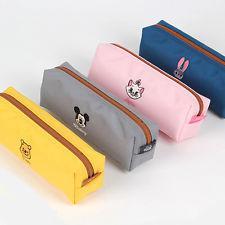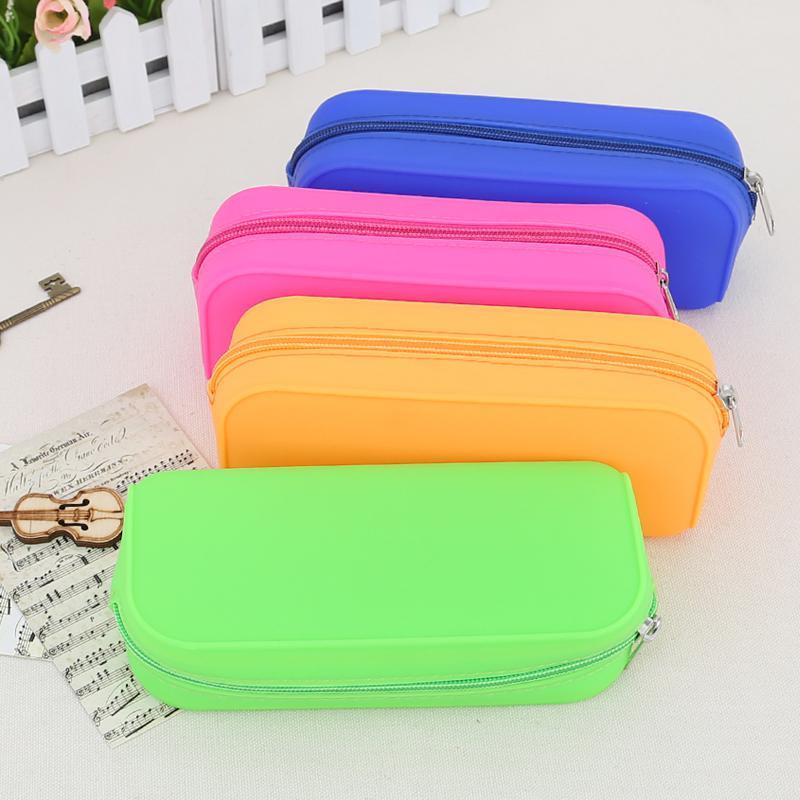The first image is the image on the left, the second image is the image on the right. Given the left and right images, does the statement "There are four bags/pencil-cases in the left image." hold true? Answer yes or no. Yes. The first image is the image on the left, the second image is the image on the right. For the images displayed, is the sentence "There are at least 8 zippered pouches." factually correct? Answer yes or no. Yes. 